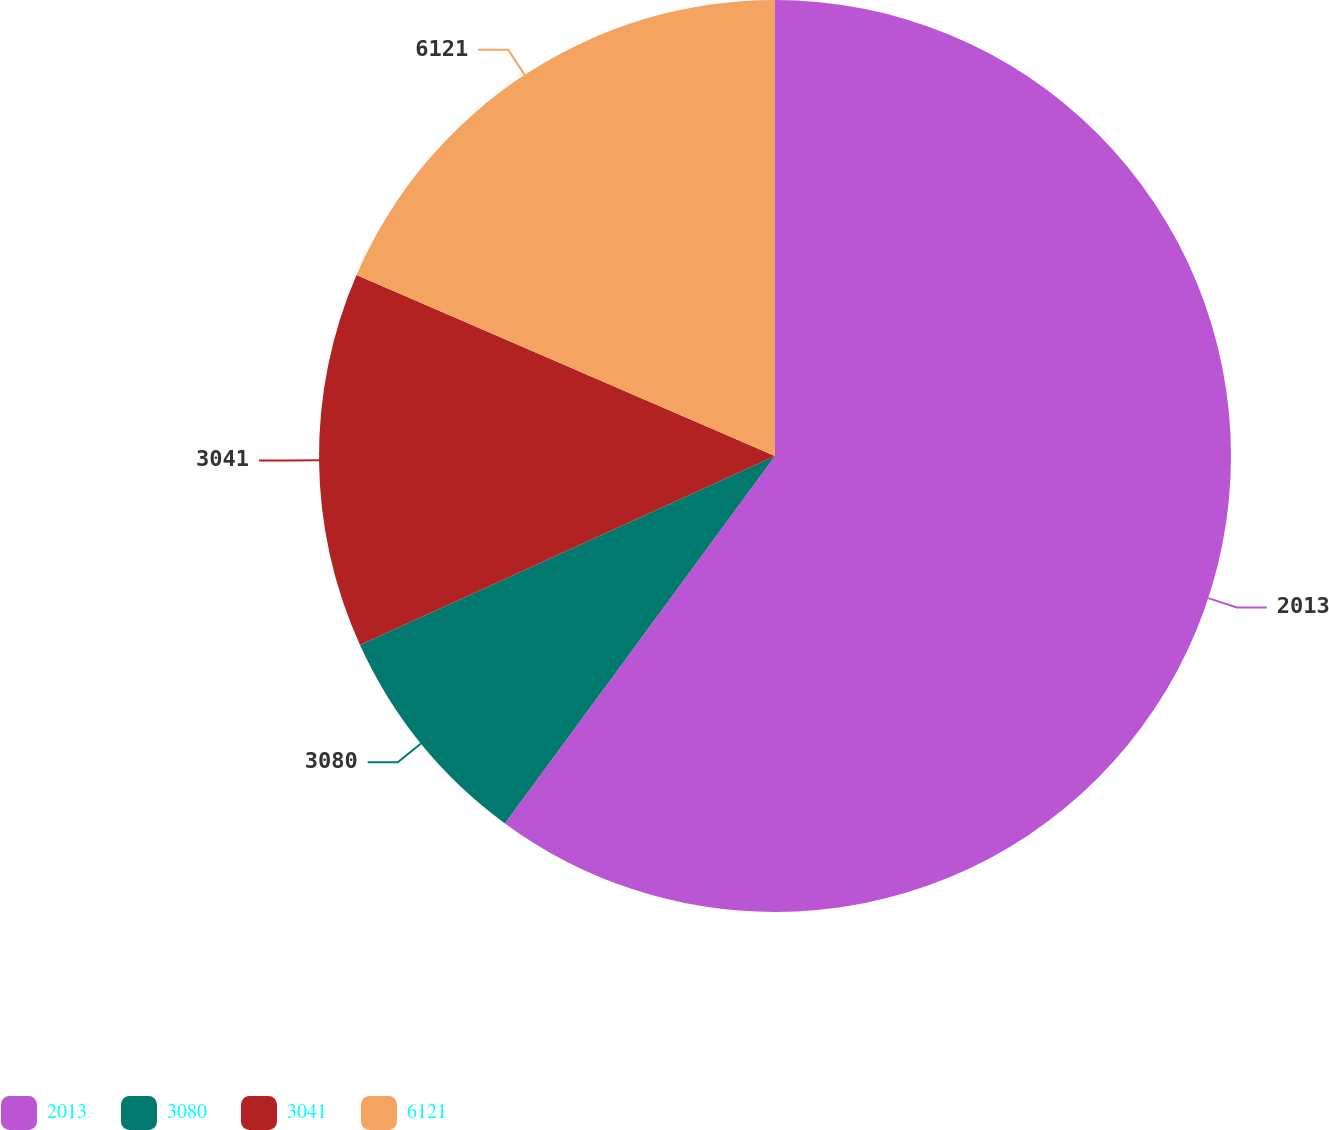<chart> <loc_0><loc_0><loc_500><loc_500><pie_chart><fcel>2013<fcel>3080<fcel>3041<fcel>6121<nl><fcel>60.09%<fcel>8.11%<fcel>13.3%<fcel>18.5%<nl></chart> 